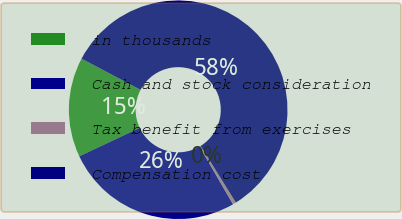<chart> <loc_0><loc_0><loc_500><loc_500><pie_chart><fcel>in thousands<fcel>Cash and stock consideration<fcel>Tax benefit from exercises<fcel>Compensation cost<nl><fcel>14.74%<fcel>26.36%<fcel>0.48%<fcel>58.41%<nl></chart> 